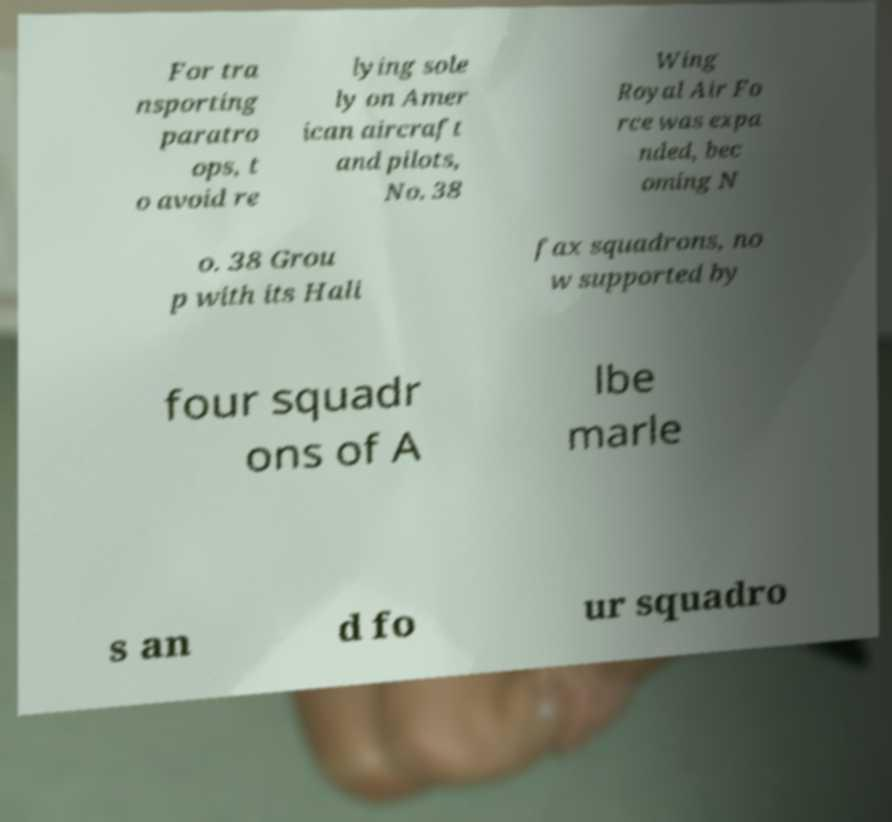Please identify and transcribe the text found in this image. For tra nsporting paratro ops, t o avoid re lying sole ly on Amer ican aircraft and pilots, No. 38 Wing Royal Air Fo rce was expa nded, bec oming N o. 38 Grou p with its Hali fax squadrons, no w supported by four squadr ons of A lbe marle s an d fo ur squadro 